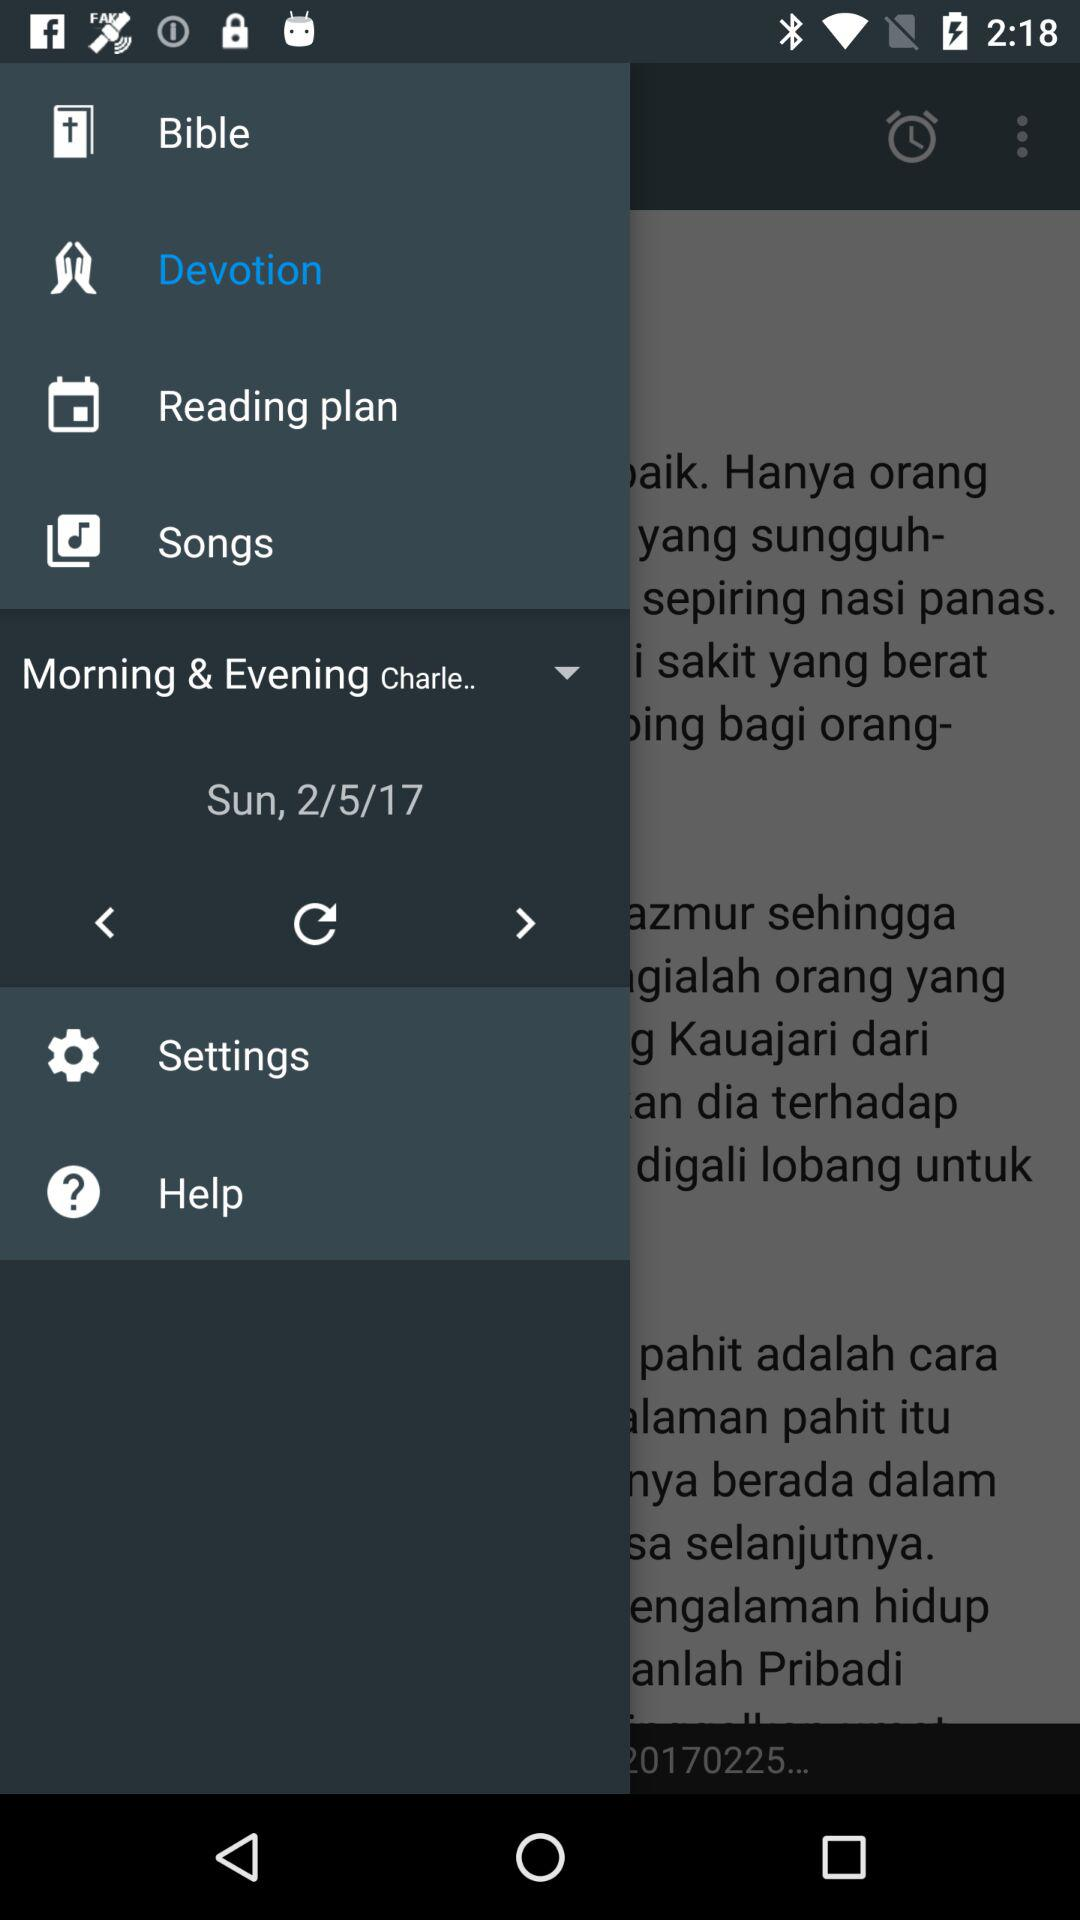What is the date? The date is Sunday, February 5, 2017. 